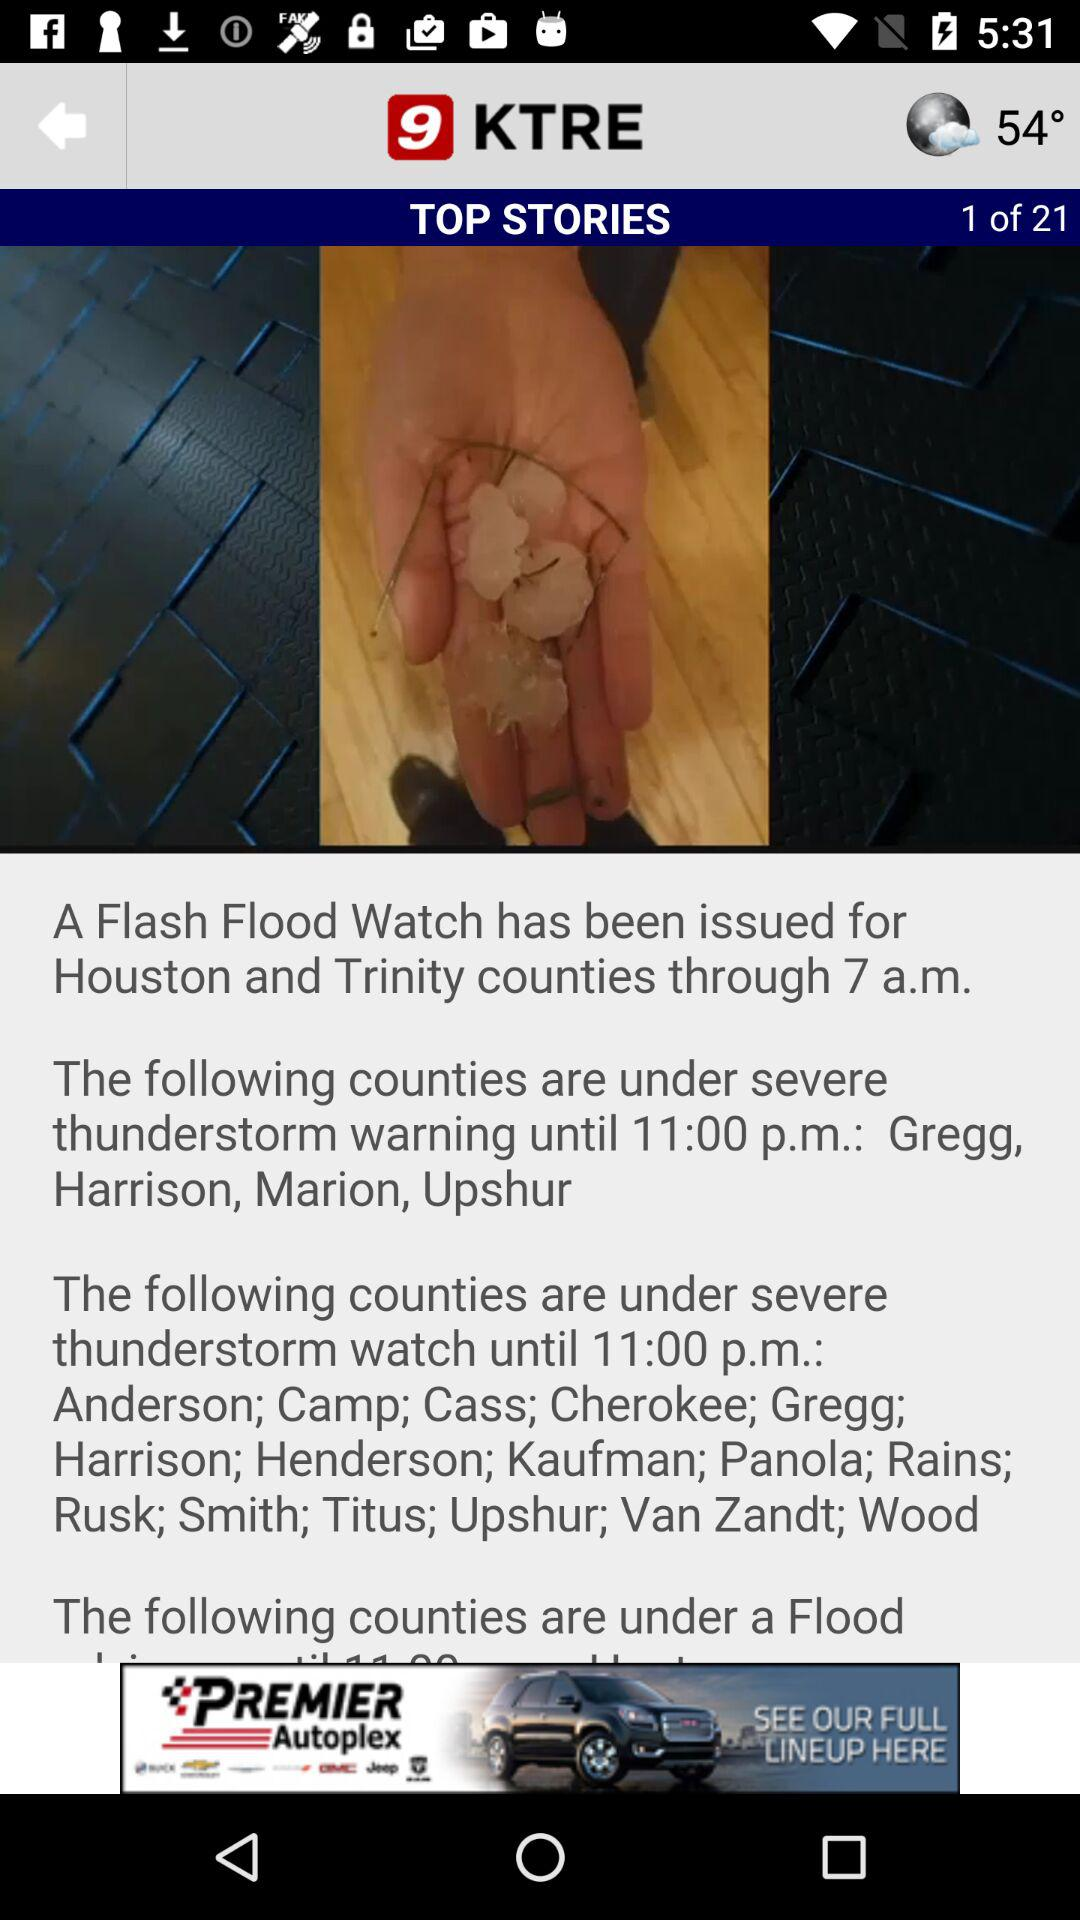What is the temperature? The temperature is 54 degrees. 